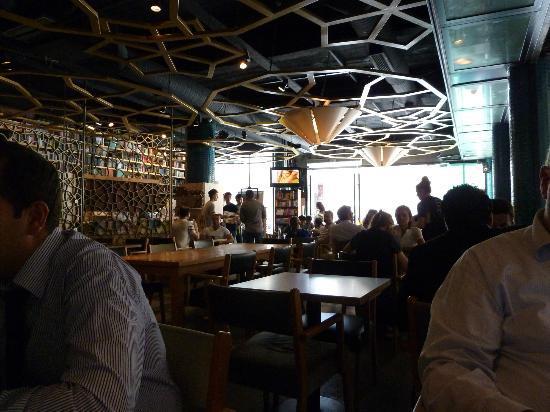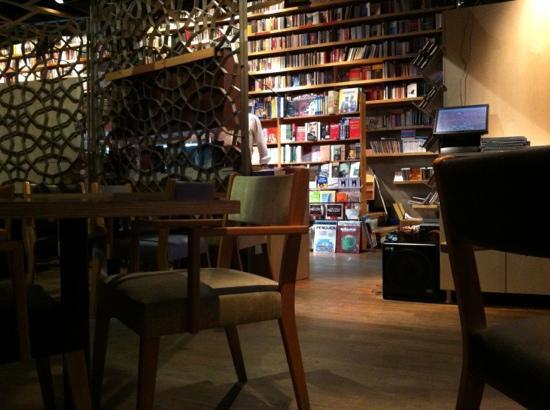The first image is the image on the left, the second image is the image on the right. Evaluate the accuracy of this statement regarding the images: "The right image shows the interior of a restaurant with cone-shaped light fixtures on a ceiling with suspended circles containing geometric patterns that repeat on the right wall.". Is it true? Answer yes or no. No. 